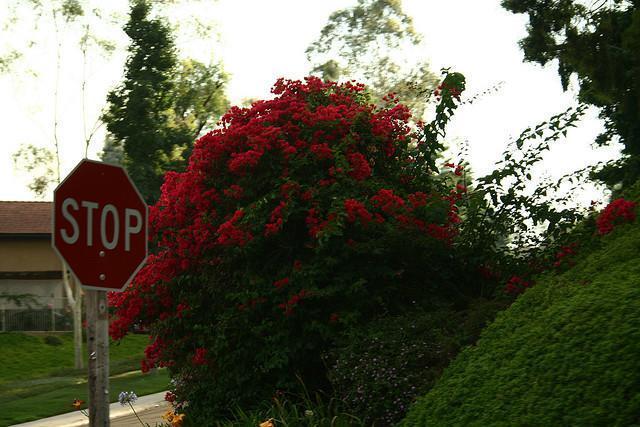How many zebras are behind the giraffes?
Give a very brief answer. 0. 